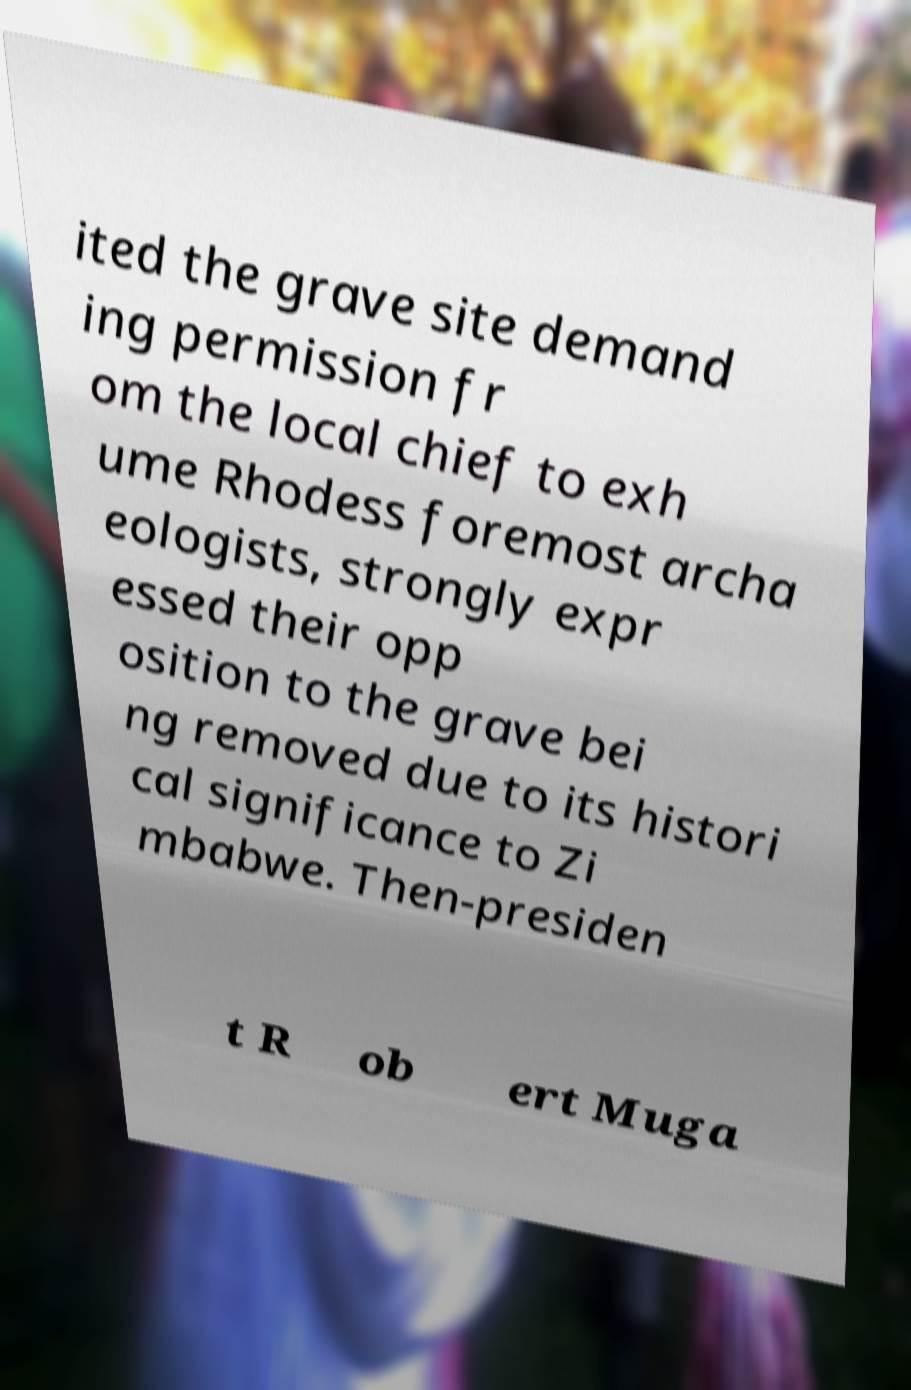For documentation purposes, I need the text within this image transcribed. Could you provide that? ited the grave site demand ing permission fr om the local chief to exh ume Rhodess foremost archa eologists, strongly expr essed their opp osition to the grave bei ng removed due to its histori cal significance to Zi mbabwe. Then-presiden t R ob ert Muga 